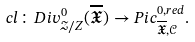<formula> <loc_0><loc_0><loc_500><loc_500>c l \colon D i v _ { \mathcal { Z } / Z } ^ { 0 } ( \overline { \mathfrak { X } } ) \rightarrow P i c _ { \overline { \mathfrak { X } } , \mathcal { C } } ^ { 0 , r e d } .</formula> 